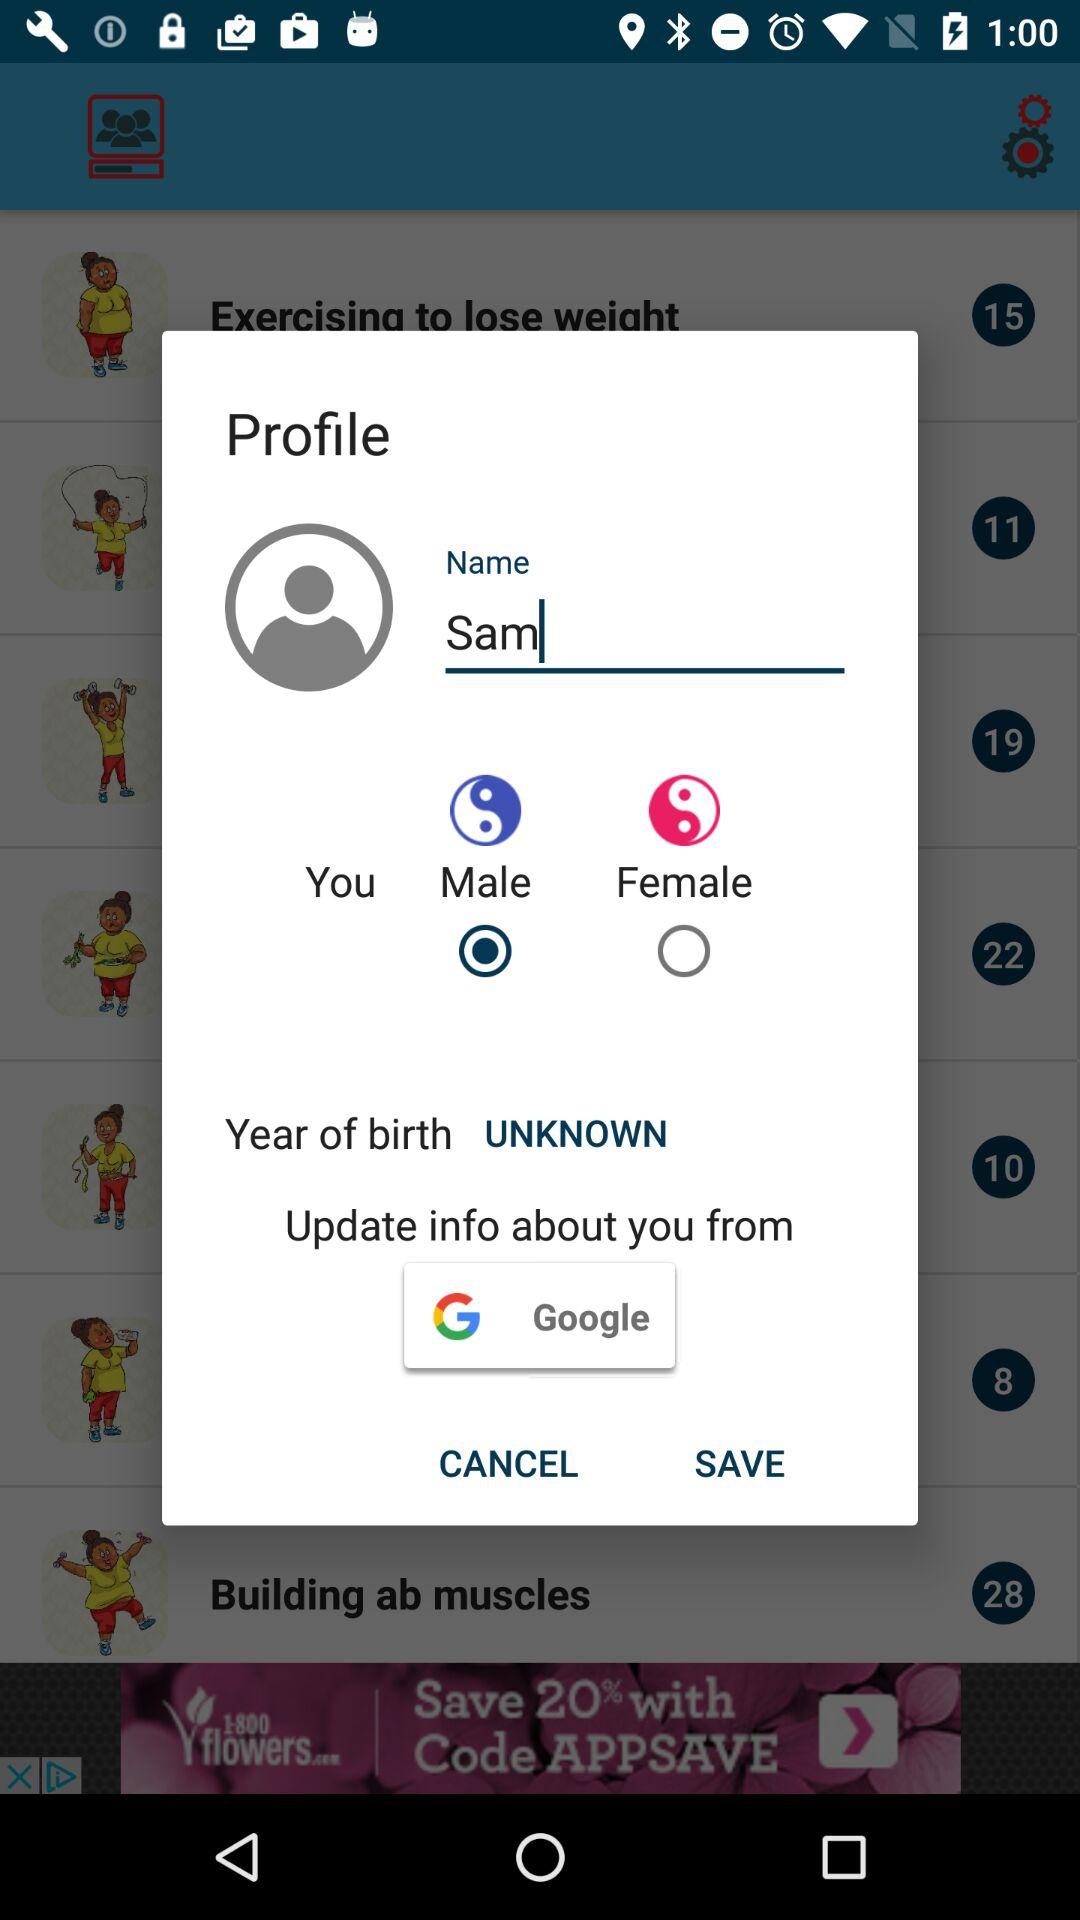What is the name of the user? The name of the user is Sam. 